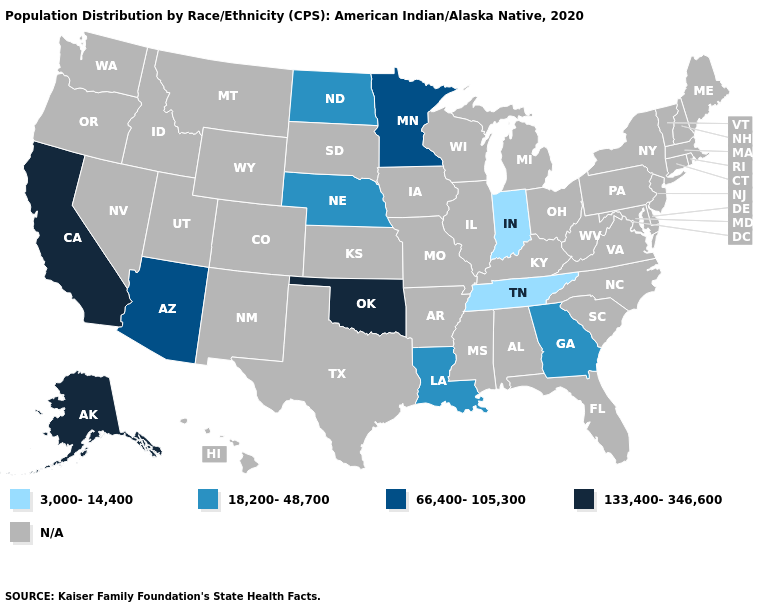Name the states that have a value in the range 133,400-346,600?
Short answer required. Alaska, California, Oklahoma. Does Oklahoma have the lowest value in the USA?
Short answer required. No. What is the highest value in the USA?
Give a very brief answer. 133,400-346,600. Which states hav the highest value in the West?
Answer briefly. Alaska, California. Name the states that have a value in the range 133,400-346,600?
Write a very short answer. Alaska, California, Oklahoma. What is the value of South Carolina?
Concise answer only. N/A. What is the value of Nebraska?
Give a very brief answer. 18,200-48,700. Name the states that have a value in the range 133,400-346,600?
Concise answer only. Alaska, California, Oklahoma. What is the value of Nevada?
Write a very short answer. N/A. Which states hav the highest value in the MidWest?
Be succinct. Minnesota. What is the lowest value in states that border Wisconsin?
Keep it brief. 66,400-105,300. Does the map have missing data?
Answer briefly. Yes. Name the states that have a value in the range N/A?
Answer briefly. Alabama, Arkansas, Colorado, Connecticut, Delaware, Florida, Hawaii, Idaho, Illinois, Iowa, Kansas, Kentucky, Maine, Maryland, Massachusetts, Michigan, Mississippi, Missouri, Montana, Nevada, New Hampshire, New Jersey, New Mexico, New York, North Carolina, Ohio, Oregon, Pennsylvania, Rhode Island, South Carolina, South Dakota, Texas, Utah, Vermont, Virginia, Washington, West Virginia, Wisconsin, Wyoming. 